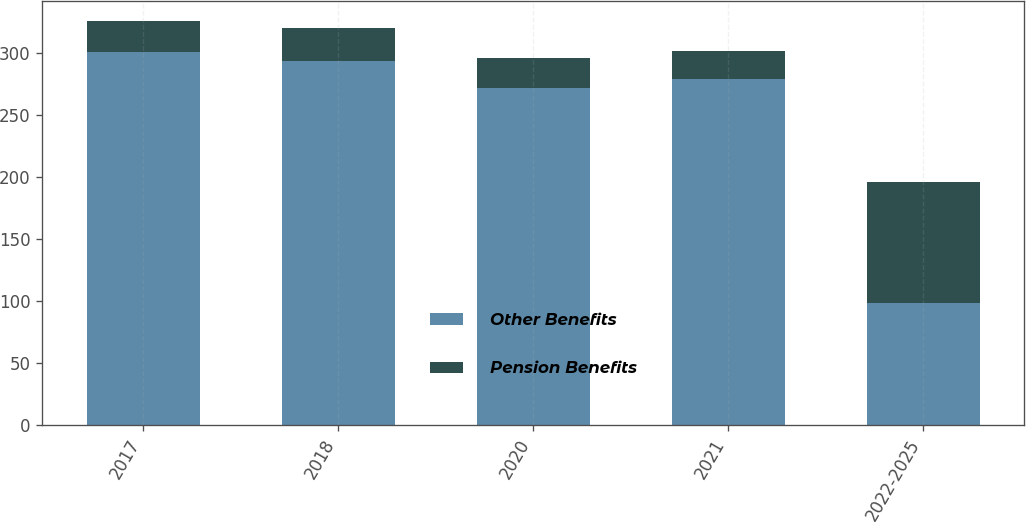Convert chart to OTSL. <chart><loc_0><loc_0><loc_500><loc_500><stacked_bar_chart><ecel><fcel>2017<fcel>2018<fcel>2020<fcel>2021<fcel>2022-2025<nl><fcel>Other Benefits<fcel>301<fcel>294<fcel>272<fcel>279<fcel>98<nl><fcel>Pension Benefits<fcel>25<fcel>26<fcel>24<fcel>23<fcel>98<nl></chart> 